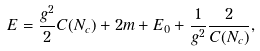<formula> <loc_0><loc_0><loc_500><loc_500>E = \frac { g ^ { 2 } } { 2 } C ( N _ { c } ) + 2 m + E _ { 0 } + \frac { 1 } { g ^ { 2 } } \frac { 2 } { C ( N _ { c } ) } ,</formula> 